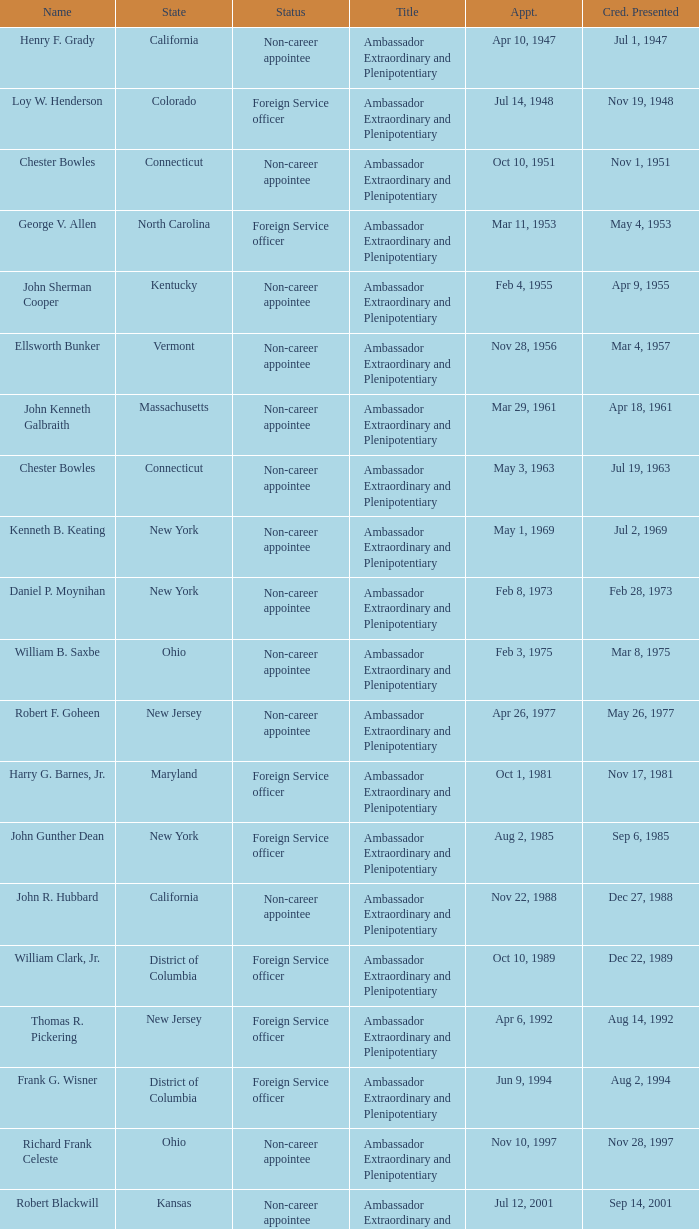What is the title for david campbell mulford? Ambassador Extraordinary and Plenipotentiary. I'm looking to parse the entire table for insights. Could you assist me with that? {'header': ['Name', 'State', 'Status', 'Title', 'Appt.', 'Cred. Presented'], 'rows': [['Henry F. Grady', 'California', 'Non-career appointee', 'Ambassador Extraordinary and Plenipotentiary', 'Apr 10, 1947', 'Jul 1, 1947'], ['Loy W. Henderson', 'Colorado', 'Foreign Service officer', 'Ambassador Extraordinary and Plenipotentiary', 'Jul 14, 1948', 'Nov 19, 1948'], ['Chester Bowles', 'Connecticut', 'Non-career appointee', 'Ambassador Extraordinary and Plenipotentiary', 'Oct 10, 1951', 'Nov 1, 1951'], ['George V. Allen', 'North Carolina', 'Foreign Service officer', 'Ambassador Extraordinary and Plenipotentiary', 'Mar 11, 1953', 'May 4, 1953'], ['John Sherman Cooper', 'Kentucky', 'Non-career appointee', 'Ambassador Extraordinary and Plenipotentiary', 'Feb 4, 1955', 'Apr 9, 1955'], ['Ellsworth Bunker', 'Vermont', 'Non-career appointee', 'Ambassador Extraordinary and Plenipotentiary', 'Nov 28, 1956', 'Mar 4, 1957'], ['John Kenneth Galbraith', 'Massachusetts', 'Non-career appointee', 'Ambassador Extraordinary and Plenipotentiary', 'Mar 29, 1961', 'Apr 18, 1961'], ['Chester Bowles', 'Connecticut', 'Non-career appointee', 'Ambassador Extraordinary and Plenipotentiary', 'May 3, 1963', 'Jul 19, 1963'], ['Kenneth B. Keating', 'New York', 'Non-career appointee', 'Ambassador Extraordinary and Plenipotentiary', 'May 1, 1969', 'Jul 2, 1969'], ['Daniel P. Moynihan', 'New York', 'Non-career appointee', 'Ambassador Extraordinary and Plenipotentiary', 'Feb 8, 1973', 'Feb 28, 1973'], ['William B. Saxbe', 'Ohio', 'Non-career appointee', 'Ambassador Extraordinary and Plenipotentiary', 'Feb 3, 1975', 'Mar 8, 1975'], ['Robert F. Goheen', 'New Jersey', 'Non-career appointee', 'Ambassador Extraordinary and Plenipotentiary', 'Apr 26, 1977', 'May 26, 1977'], ['Harry G. Barnes, Jr.', 'Maryland', 'Foreign Service officer', 'Ambassador Extraordinary and Plenipotentiary', 'Oct 1, 1981', 'Nov 17, 1981'], ['John Gunther Dean', 'New York', 'Foreign Service officer', 'Ambassador Extraordinary and Plenipotentiary', 'Aug 2, 1985', 'Sep 6, 1985'], ['John R. Hubbard', 'California', 'Non-career appointee', 'Ambassador Extraordinary and Plenipotentiary', 'Nov 22, 1988', 'Dec 27, 1988'], ['William Clark, Jr.', 'District of Columbia', 'Foreign Service officer', 'Ambassador Extraordinary and Plenipotentiary', 'Oct 10, 1989', 'Dec 22, 1989'], ['Thomas R. Pickering', 'New Jersey', 'Foreign Service officer', 'Ambassador Extraordinary and Plenipotentiary', 'Apr 6, 1992', 'Aug 14, 1992'], ['Frank G. Wisner', 'District of Columbia', 'Foreign Service officer', 'Ambassador Extraordinary and Plenipotentiary', 'Jun 9, 1994', 'Aug 2, 1994'], ['Richard Frank Celeste', 'Ohio', 'Non-career appointee', 'Ambassador Extraordinary and Plenipotentiary', 'Nov 10, 1997', 'Nov 28, 1997'], ['Robert Blackwill', 'Kansas', 'Non-career appointee', 'Ambassador Extraordinary and Plenipotentiary', 'Jul 12, 2001', 'Sep 14, 2001'], ['David Campbell Mulford', 'Illinois', 'Non-career officer', 'Ambassador Extraordinary and Plenipotentiary', 'Dec 12, 2003', 'Feb 23, 2004'], ['Timothy J. Roemer', 'Indiana', 'Non-career appointee', 'Ambassador Extraordinary and Plenipotentiary', 'Jul 23, 2009', 'Aug 11, 2009'], ['Albert Peter Burleigh', 'California', 'Foreign Service officer', "Charge d'affaires", 'June 2011', 'Left post 2012'], ['Nancy Jo Powell', 'Iowa', 'Foreign Service officer', 'Ambassador Extraordinary and Plenipotentiary', 'February 7, 2012', 'April 19, 2012']]} 